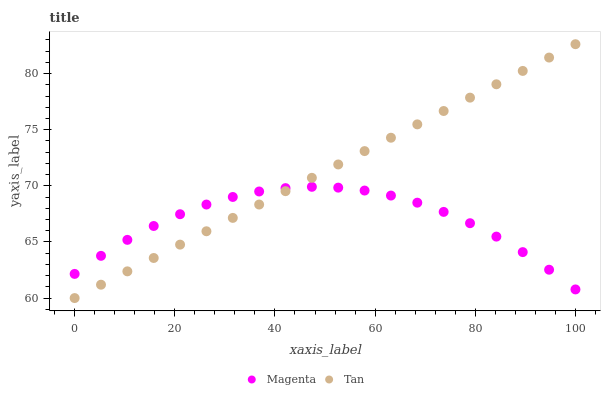Does Magenta have the minimum area under the curve?
Answer yes or no. Yes. Does Tan have the maximum area under the curve?
Answer yes or no. Yes. Does Tan have the minimum area under the curve?
Answer yes or no. No. Is Tan the smoothest?
Answer yes or no. Yes. Is Magenta the roughest?
Answer yes or no. Yes. Is Tan the roughest?
Answer yes or no. No. Does Tan have the lowest value?
Answer yes or no. Yes. Does Tan have the highest value?
Answer yes or no. Yes. Does Tan intersect Magenta?
Answer yes or no. Yes. Is Tan less than Magenta?
Answer yes or no. No. Is Tan greater than Magenta?
Answer yes or no. No. 